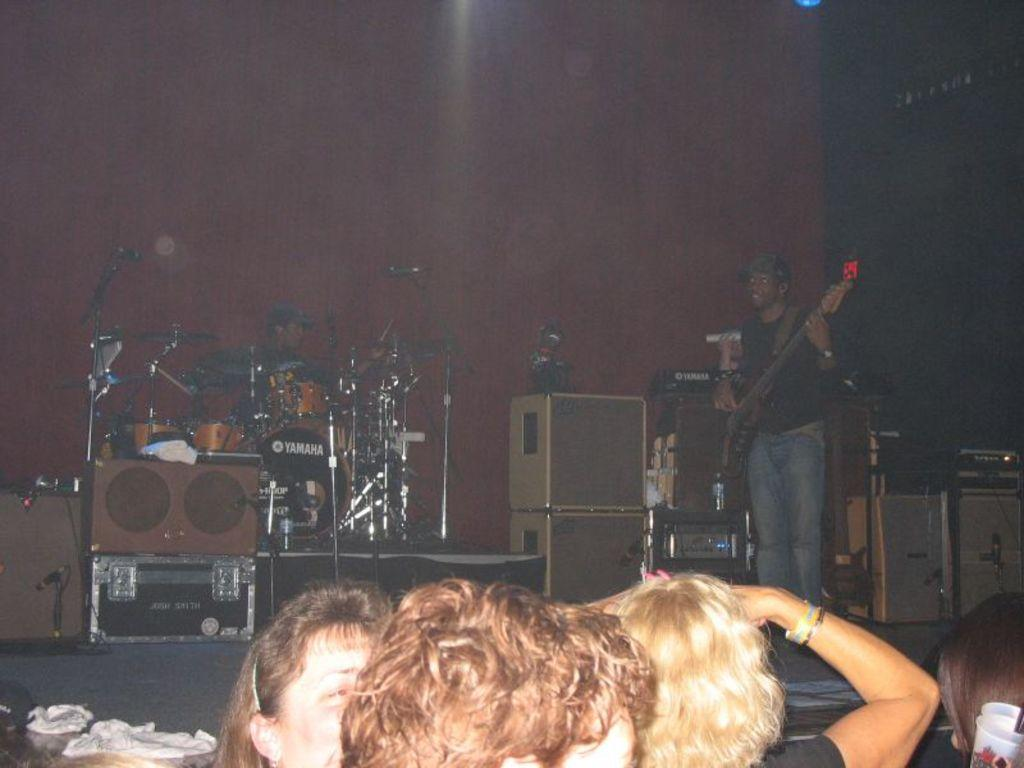What is happening in the image? There are people in the image, and they are playing musical instruments on a stage. What can be seen in the background of the image? There is a wall in the background of the image. What month is it in the image? The month cannot be determined from the image, as there is no information about the time of year or any specific date. 